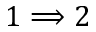<formula> <loc_0><loc_0><loc_500><loc_500>1 \Longrightarrow 2</formula> 